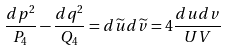<formula> <loc_0><loc_0><loc_500><loc_500>\frac { d p ^ { 2 } } { P _ { 4 } } - \frac { d q ^ { 2 } } { Q _ { 4 } } = d \widetilde { u } d \widetilde { v } = 4 \frac { d u d v } { U V }</formula> 